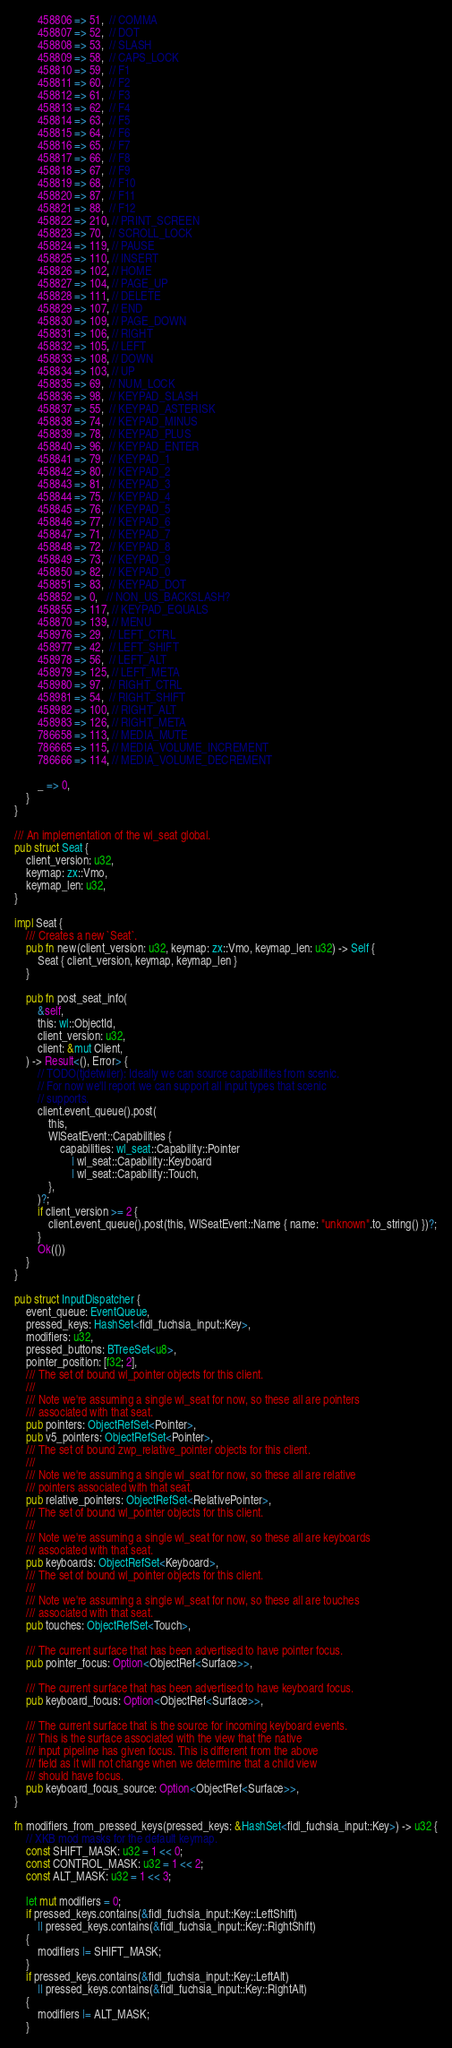Convert code to text. <code><loc_0><loc_0><loc_500><loc_500><_Rust_>        458806 => 51,  // COMMA
        458807 => 52,  // DOT
        458808 => 53,  // SLASH
        458809 => 58,  // CAPS_LOCK
        458810 => 59,  // F1
        458811 => 60,  // F2
        458812 => 61,  // F3
        458813 => 62,  // F4
        458814 => 63,  // F5
        458815 => 64,  // F6
        458816 => 65,  // F7
        458817 => 66,  // F8
        458818 => 67,  // F9
        458819 => 68,  // F10
        458820 => 87,  // F11
        458821 => 88,  // F12
        458822 => 210, // PRINT_SCREEN
        458823 => 70,  // SCROLL_LOCK
        458824 => 119, // PAUSE
        458825 => 110, // INSERT
        458826 => 102, // HOME
        458827 => 104, // PAGE_UP
        458828 => 111, // DELETE
        458829 => 107, // END
        458830 => 109, // PAGE_DOWN
        458831 => 106, // RIGHT
        458832 => 105, // LEFT
        458833 => 108, // DOWN
        458834 => 103, // UP
        458835 => 69,  // NUM_LOCK
        458836 => 98,  // KEYPAD_SLASH
        458837 => 55,  // KEYPAD_ASTERISK
        458838 => 74,  // KEYPAD_MINUS
        458839 => 78,  // KEYPAD_PLUS
        458840 => 96,  // KEYPAD_ENTER
        458841 => 79,  // KEYPAD_1
        458842 => 80,  // KEYPAD_2
        458843 => 81,  // KEYPAD_3
        458844 => 75,  // KEYPAD_4
        458845 => 76,  // KEYPAD_5
        458846 => 77,  // KEYPAD_6
        458847 => 71,  // KEYPAD_7
        458848 => 72,  // KEYPAD_8
        458849 => 73,  // KEYPAD_9
        458850 => 82,  // KEYPAD_0
        458851 => 83,  // KEYPAD_DOT
        458852 => 0,   // NON_US_BACKSLASH?
        458855 => 117, // KEYPAD_EQUALS
        458870 => 139, // MENU
        458976 => 29,  // LEFT_CTRL
        458977 => 42,  // LEFT_SHIFT
        458978 => 56,  // LEFT_ALT
        458979 => 125, // LEFT_META
        458980 => 97,  // RIGHT_CTRL
        458981 => 54,  // RIGHT_SHIFT
        458982 => 100, // RIGHT_ALT
        458983 => 126, // RIGHT_META
        786658 => 113, // MEDIA_MUTE
        786665 => 115, // MEDIA_VOLUME_INCREMENT
        786666 => 114, // MEDIA_VOLUME_DECREMENT

        _ => 0,
    }
}

/// An implementation of the wl_seat global.
pub struct Seat {
    client_version: u32,
    keymap: zx::Vmo,
    keymap_len: u32,
}

impl Seat {
    /// Creates a new `Seat`.
    pub fn new(client_version: u32, keymap: zx::Vmo, keymap_len: u32) -> Self {
        Seat { client_version, keymap, keymap_len }
    }

    pub fn post_seat_info(
        &self,
        this: wl::ObjectId,
        client_version: u32,
        client: &mut Client,
    ) -> Result<(), Error> {
        // TODO(tjdetwiler): Ideally we can source capabilities from scenic.
        // For now we'll report we can support all input types that scenic
        // supports.
        client.event_queue().post(
            this,
            WlSeatEvent::Capabilities {
                capabilities: wl_seat::Capability::Pointer
                    | wl_seat::Capability::Keyboard
                    | wl_seat::Capability::Touch,
            },
        )?;
        if client_version >= 2 {
            client.event_queue().post(this, WlSeatEvent::Name { name: "unknown".to_string() })?;
        }
        Ok(())
    }
}

pub struct InputDispatcher {
    event_queue: EventQueue,
    pressed_keys: HashSet<fidl_fuchsia_input::Key>,
    modifiers: u32,
    pressed_buttons: BTreeSet<u8>,
    pointer_position: [f32; 2],
    /// The set of bound wl_pointer objects for this client.
    ///
    /// Note we're assuming a single wl_seat for now, so these all are pointers
    /// associated with that seat.
    pub pointers: ObjectRefSet<Pointer>,
    pub v5_pointers: ObjectRefSet<Pointer>,
    /// The set of bound zwp_relative_pointer objects for this client.
    ///
    /// Note we're assuming a single wl_seat for now, so these all are relative
    /// pointers associated with that seat.
    pub relative_pointers: ObjectRefSet<RelativePointer>,
    /// The set of bound wl_pointer objects for this client.
    ///
    /// Note we're assuming a single wl_seat for now, so these all are keyboards
    /// associated with that seat.
    pub keyboards: ObjectRefSet<Keyboard>,
    /// The set of bound wl_pointer objects for this client.
    ///
    /// Note we're assuming a single wl_seat for now, so these all are touches
    /// associated with that seat.
    pub touches: ObjectRefSet<Touch>,

    /// The current surface that has been advertised to have pointer focus.
    pub pointer_focus: Option<ObjectRef<Surface>>,

    /// The current surface that has been advertised to have keyboard focus.
    pub keyboard_focus: Option<ObjectRef<Surface>>,

    /// The current surface that is the source for incoming keyboard events.
    /// This is the surface associated with the view that the native
    /// input pipeline has given focus. This is different from the above
    /// field as it will not change when we determine that a child view
    /// should have focus.
    pub keyboard_focus_source: Option<ObjectRef<Surface>>,
}

fn modifiers_from_pressed_keys(pressed_keys: &HashSet<fidl_fuchsia_input::Key>) -> u32 {
    // XKB mod masks for the default keymap.
    const SHIFT_MASK: u32 = 1 << 0;
    const CONTROL_MASK: u32 = 1 << 2;
    const ALT_MASK: u32 = 1 << 3;

    let mut modifiers = 0;
    if pressed_keys.contains(&fidl_fuchsia_input::Key::LeftShift)
        || pressed_keys.contains(&fidl_fuchsia_input::Key::RightShift)
    {
        modifiers |= SHIFT_MASK;
    }
    if pressed_keys.contains(&fidl_fuchsia_input::Key::LeftAlt)
        || pressed_keys.contains(&fidl_fuchsia_input::Key::RightAlt)
    {
        modifiers |= ALT_MASK;
    }</code> 